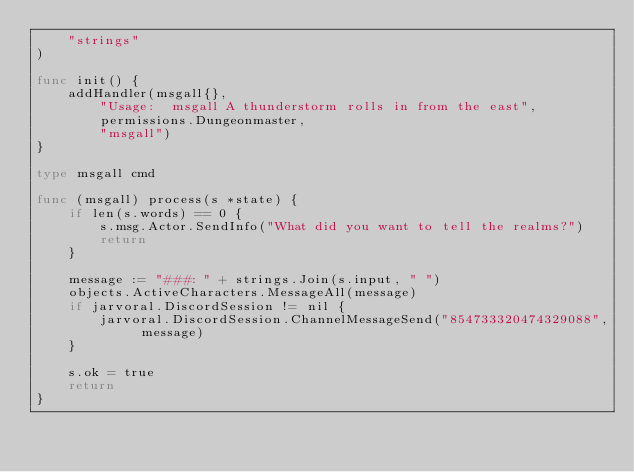<code> <loc_0><loc_0><loc_500><loc_500><_Go_>	"strings"
)

func init() {
	addHandler(msgall{},
		"Usage:  msgall A thunderstorm rolls in from the east",
		permissions.Dungeonmaster,
		"msgall")
}

type msgall cmd

func (msgall) process(s *state) {
	if len(s.words) == 0 {
		s.msg.Actor.SendInfo("What did you want to tell the realms?")
		return
	}

	message := "###: " + strings.Join(s.input, " ")
	objects.ActiveCharacters.MessageAll(message)
	if jarvoral.DiscordSession != nil {
		jarvoral.DiscordSession.ChannelMessageSend("854733320474329088", message)
	}

	s.ok = true
	return
}
</code> 